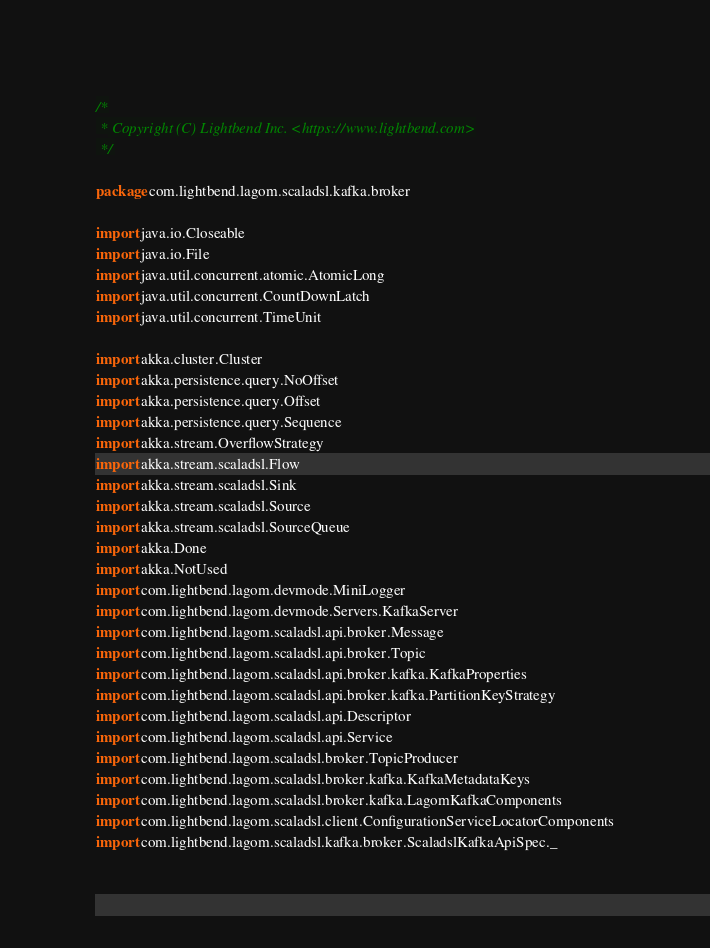Convert code to text. <code><loc_0><loc_0><loc_500><loc_500><_Scala_>/*
 * Copyright (C) Lightbend Inc. <https://www.lightbend.com>
 */

package com.lightbend.lagom.scaladsl.kafka.broker

import java.io.Closeable
import java.io.File
import java.util.concurrent.atomic.AtomicLong
import java.util.concurrent.CountDownLatch
import java.util.concurrent.TimeUnit

import akka.cluster.Cluster
import akka.persistence.query.NoOffset
import akka.persistence.query.Offset
import akka.persistence.query.Sequence
import akka.stream.OverflowStrategy
import akka.stream.scaladsl.Flow
import akka.stream.scaladsl.Sink
import akka.stream.scaladsl.Source
import akka.stream.scaladsl.SourceQueue
import akka.Done
import akka.NotUsed
import com.lightbend.lagom.devmode.MiniLogger
import com.lightbend.lagom.devmode.Servers.KafkaServer
import com.lightbend.lagom.scaladsl.api.broker.Message
import com.lightbend.lagom.scaladsl.api.broker.Topic
import com.lightbend.lagom.scaladsl.api.broker.kafka.KafkaProperties
import com.lightbend.lagom.scaladsl.api.broker.kafka.PartitionKeyStrategy
import com.lightbend.lagom.scaladsl.api.Descriptor
import com.lightbend.lagom.scaladsl.api.Service
import com.lightbend.lagom.scaladsl.broker.TopicProducer
import com.lightbend.lagom.scaladsl.broker.kafka.KafkaMetadataKeys
import com.lightbend.lagom.scaladsl.broker.kafka.LagomKafkaComponents
import com.lightbend.lagom.scaladsl.client.ConfigurationServiceLocatorComponents
import com.lightbend.lagom.scaladsl.kafka.broker.ScaladslKafkaApiSpec._</code> 